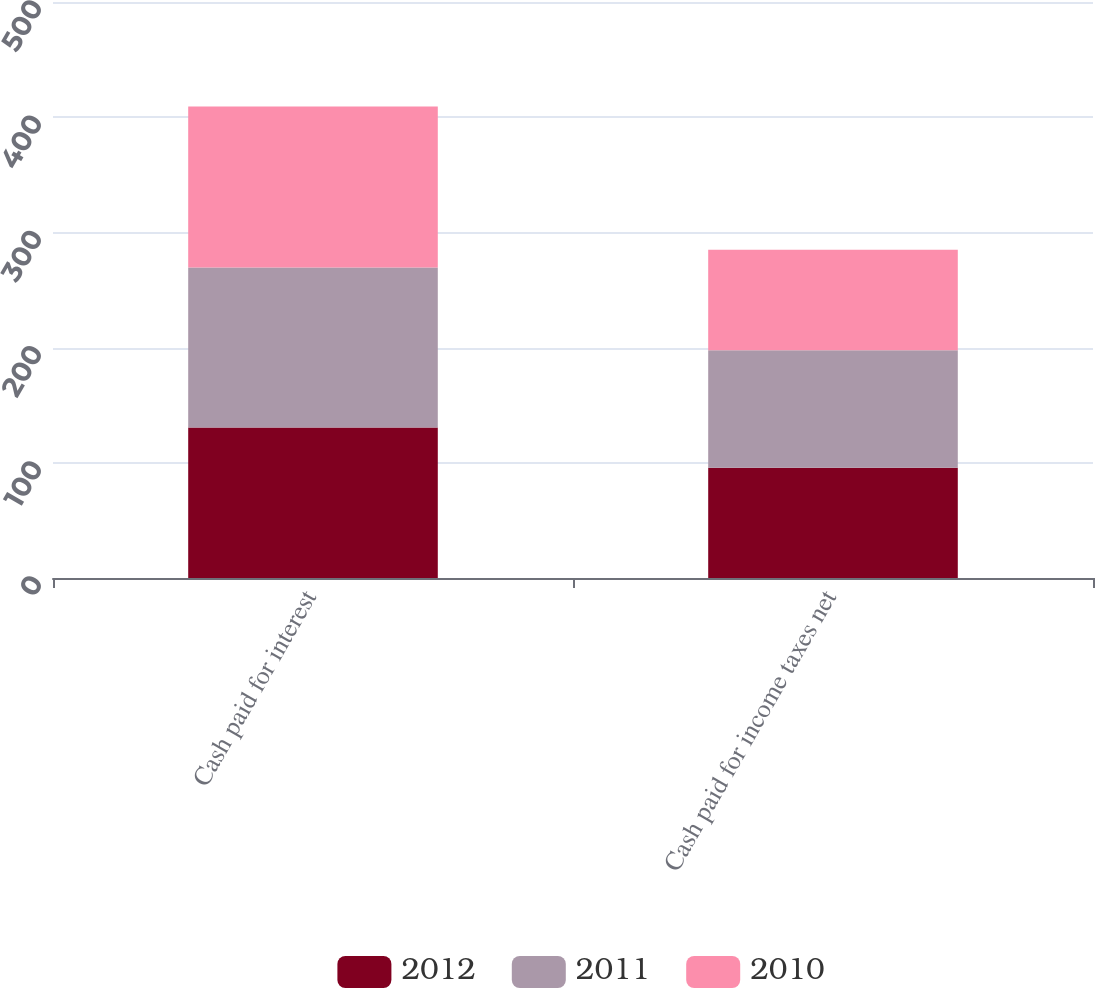Convert chart. <chart><loc_0><loc_0><loc_500><loc_500><stacked_bar_chart><ecel><fcel>Cash paid for interest<fcel>Cash paid for income taxes net<nl><fcel>2012<fcel>130.6<fcel>95.7<nl><fcel>2011<fcel>138.9<fcel>102<nl><fcel>2010<fcel>139.8<fcel>87.3<nl></chart> 